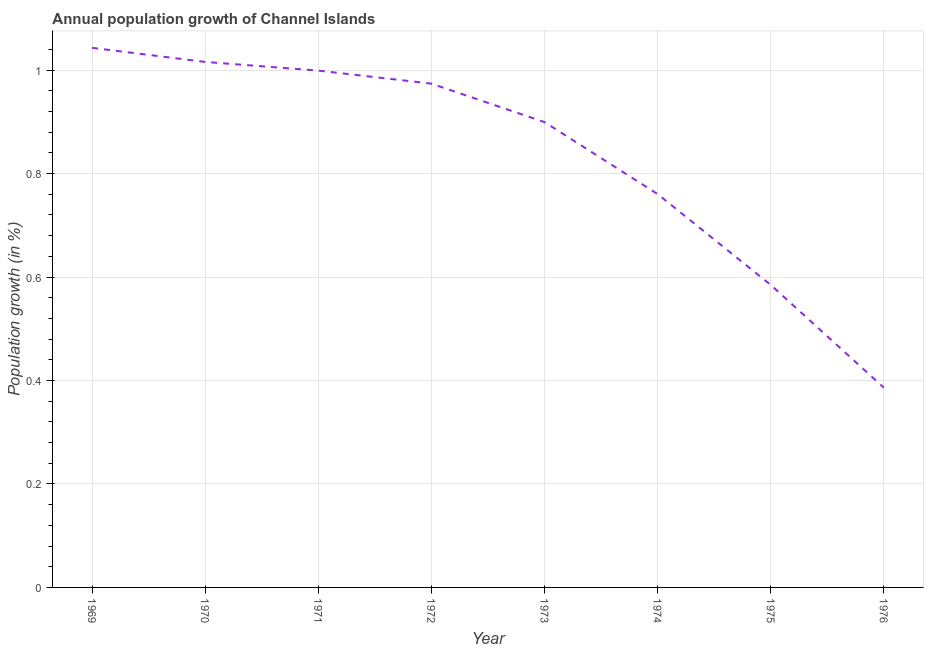What is the population growth in 1973?
Offer a very short reply. 0.9. Across all years, what is the maximum population growth?
Provide a succinct answer. 1.04. Across all years, what is the minimum population growth?
Make the answer very short. 0.39. In which year was the population growth maximum?
Your answer should be very brief. 1969. In which year was the population growth minimum?
Keep it short and to the point. 1976. What is the sum of the population growth?
Provide a succinct answer. 6.66. What is the difference between the population growth in 1969 and 1972?
Offer a terse response. 0.07. What is the average population growth per year?
Make the answer very short. 0.83. What is the median population growth?
Provide a short and direct response. 0.94. In how many years, is the population growth greater than 1 %?
Give a very brief answer. 2. Do a majority of the years between 1973 and 1970 (inclusive) have population growth greater than 0.56 %?
Keep it short and to the point. Yes. What is the ratio of the population growth in 1970 to that in 1973?
Keep it short and to the point. 1.13. Is the difference between the population growth in 1969 and 1976 greater than the difference between any two years?
Keep it short and to the point. Yes. What is the difference between the highest and the second highest population growth?
Offer a very short reply. 0.03. Is the sum of the population growth in 1969 and 1972 greater than the maximum population growth across all years?
Give a very brief answer. Yes. What is the difference between the highest and the lowest population growth?
Offer a very short reply. 0.66. Does the population growth monotonically increase over the years?
Make the answer very short. No. How many years are there in the graph?
Provide a succinct answer. 8. Are the values on the major ticks of Y-axis written in scientific E-notation?
Offer a very short reply. No. What is the title of the graph?
Ensure brevity in your answer.  Annual population growth of Channel Islands. What is the label or title of the Y-axis?
Ensure brevity in your answer.  Population growth (in %). What is the Population growth (in %) of 1969?
Ensure brevity in your answer.  1.04. What is the Population growth (in %) of 1970?
Offer a terse response. 1.02. What is the Population growth (in %) of 1971?
Give a very brief answer. 1. What is the Population growth (in %) in 1972?
Keep it short and to the point. 0.97. What is the Population growth (in %) of 1973?
Offer a terse response. 0.9. What is the Population growth (in %) in 1974?
Offer a terse response. 0.76. What is the Population growth (in %) of 1975?
Give a very brief answer. 0.58. What is the Population growth (in %) in 1976?
Offer a terse response. 0.39. What is the difference between the Population growth (in %) in 1969 and 1970?
Your answer should be very brief. 0.03. What is the difference between the Population growth (in %) in 1969 and 1971?
Provide a succinct answer. 0.04. What is the difference between the Population growth (in %) in 1969 and 1972?
Your response must be concise. 0.07. What is the difference between the Population growth (in %) in 1969 and 1973?
Make the answer very short. 0.14. What is the difference between the Population growth (in %) in 1969 and 1974?
Provide a succinct answer. 0.28. What is the difference between the Population growth (in %) in 1969 and 1975?
Offer a terse response. 0.46. What is the difference between the Population growth (in %) in 1969 and 1976?
Your answer should be compact. 0.66. What is the difference between the Population growth (in %) in 1970 and 1971?
Provide a succinct answer. 0.02. What is the difference between the Population growth (in %) in 1970 and 1972?
Offer a terse response. 0.04. What is the difference between the Population growth (in %) in 1970 and 1973?
Offer a terse response. 0.12. What is the difference between the Population growth (in %) in 1970 and 1974?
Make the answer very short. 0.26. What is the difference between the Population growth (in %) in 1970 and 1975?
Provide a short and direct response. 0.43. What is the difference between the Population growth (in %) in 1970 and 1976?
Give a very brief answer. 0.63. What is the difference between the Population growth (in %) in 1971 and 1972?
Offer a very short reply. 0.03. What is the difference between the Population growth (in %) in 1971 and 1973?
Give a very brief answer. 0.1. What is the difference between the Population growth (in %) in 1971 and 1974?
Your answer should be very brief. 0.24. What is the difference between the Population growth (in %) in 1971 and 1975?
Provide a succinct answer. 0.41. What is the difference between the Population growth (in %) in 1971 and 1976?
Offer a very short reply. 0.61. What is the difference between the Population growth (in %) in 1972 and 1973?
Your answer should be very brief. 0.07. What is the difference between the Population growth (in %) in 1972 and 1974?
Offer a very short reply. 0.21. What is the difference between the Population growth (in %) in 1972 and 1975?
Your answer should be very brief. 0.39. What is the difference between the Population growth (in %) in 1972 and 1976?
Your answer should be compact. 0.59. What is the difference between the Population growth (in %) in 1973 and 1974?
Offer a very short reply. 0.14. What is the difference between the Population growth (in %) in 1973 and 1975?
Provide a succinct answer. 0.31. What is the difference between the Population growth (in %) in 1973 and 1976?
Provide a succinct answer. 0.51. What is the difference between the Population growth (in %) in 1974 and 1975?
Ensure brevity in your answer.  0.18. What is the difference between the Population growth (in %) in 1974 and 1976?
Your response must be concise. 0.37. What is the difference between the Population growth (in %) in 1975 and 1976?
Keep it short and to the point. 0.2. What is the ratio of the Population growth (in %) in 1969 to that in 1970?
Provide a succinct answer. 1.03. What is the ratio of the Population growth (in %) in 1969 to that in 1971?
Provide a succinct answer. 1.04. What is the ratio of the Population growth (in %) in 1969 to that in 1972?
Your answer should be compact. 1.07. What is the ratio of the Population growth (in %) in 1969 to that in 1973?
Provide a succinct answer. 1.16. What is the ratio of the Population growth (in %) in 1969 to that in 1974?
Offer a terse response. 1.37. What is the ratio of the Population growth (in %) in 1969 to that in 1975?
Provide a short and direct response. 1.78. What is the ratio of the Population growth (in %) in 1969 to that in 1976?
Keep it short and to the point. 2.7. What is the ratio of the Population growth (in %) in 1970 to that in 1971?
Offer a terse response. 1.02. What is the ratio of the Population growth (in %) in 1970 to that in 1972?
Provide a succinct answer. 1.04. What is the ratio of the Population growth (in %) in 1970 to that in 1973?
Your answer should be very brief. 1.13. What is the ratio of the Population growth (in %) in 1970 to that in 1974?
Ensure brevity in your answer.  1.34. What is the ratio of the Population growth (in %) in 1970 to that in 1975?
Keep it short and to the point. 1.74. What is the ratio of the Population growth (in %) in 1970 to that in 1976?
Give a very brief answer. 2.63. What is the ratio of the Population growth (in %) in 1971 to that in 1972?
Ensure brevity in your answer.  1.03. What is the ratio of the Population growth (in %) in 1971 to that in 1973?
Your answer should be compact. 1.11. What is the ratio of the Population growth (in %) in 1971 to that in 1974?
Make the answer very short. 1.31. What is the ratio of the Population growth (in %) in 1971 to that in 1975?
Give a very brief answer. 1.71. What is the ratio of the Population growth (in %) in 1971 to that in 1976?
Offer a very short reply. 2.59. What is the ratio of the Population growth (in %) in 1972 to that in 1973?
Offer a very short reply. 1.08. What is the ratio of the Population growth (in %) in 1972 to that in 1974?
Give a very brief answer. 1.28. What is the ratio of the Population growth (in %) in 1972 to that in 1975?
Keep it short and to the point. 1.67. What is the ratio of the Population growth (in %) in 1972 to that in 1976?
Offer a very short reply. 2.52. What is the ratio of the Population growth (in %) in 1973 to that in 1974?
Offer a very short reply. 1.18. What is the ratio of the Population growth (in %) in 1973 to that in 1975?
Ensure brevity in your answer.  1.54. What is the ratio of the Population growth (in %) in 1973 to that in 1976?
Your response must be concise. 2.33. What is the ratio of the Population growth (in %) in 1974 to that in 1975?
Provide a succinct answer. 1.3. What is the ratio of the Population growth (in %) in 1974 to that in 1976?
Offer a very short reply. 1.97. What is the ratio of the Population growth (in %) in 1975 to that in 1976?
Your answer should be very brief. 1.51. 